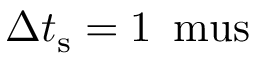<formula> <loc_0><loc_0><loc_500><loc_500>\Delta t _ { s } = 1 \, { \ m u s }</formula> 